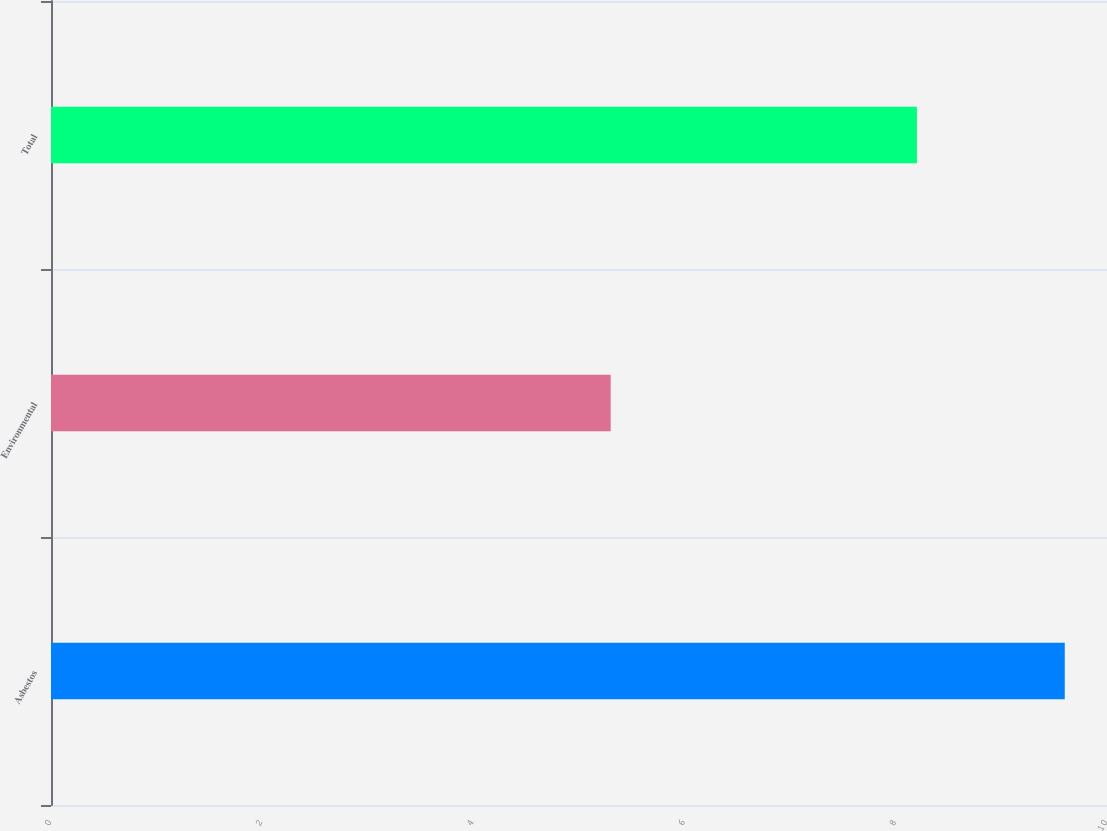<chart> <loc_0><loc_0><loc_500><loc_500><bar_chart><fcel>Asbestos<fcel>Environmental<fcel>Total<nl><fcel>9.6<fcel>5.3<fcel>8.2<nl></chart> 